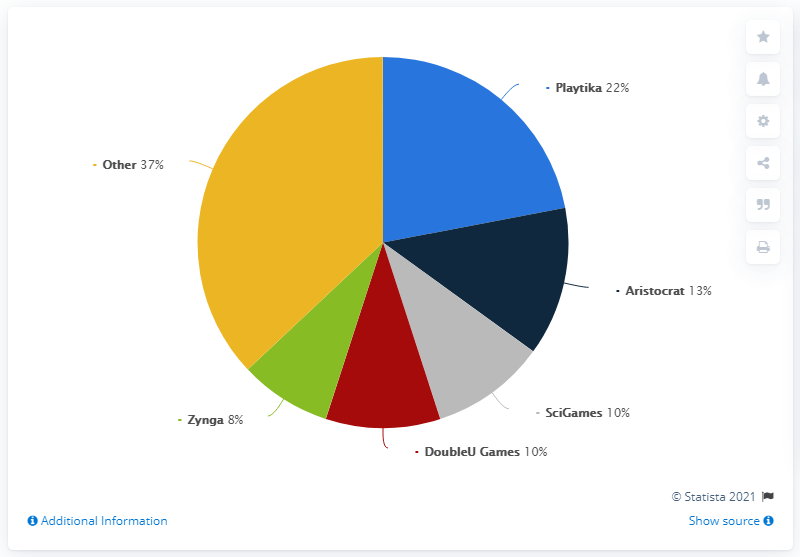List a handful of essential elements in this visual. According to a report, Playtika, a Israeli mobile gaming publisher, accounted for 22 percent of the global social casino gaming market in 2020. 